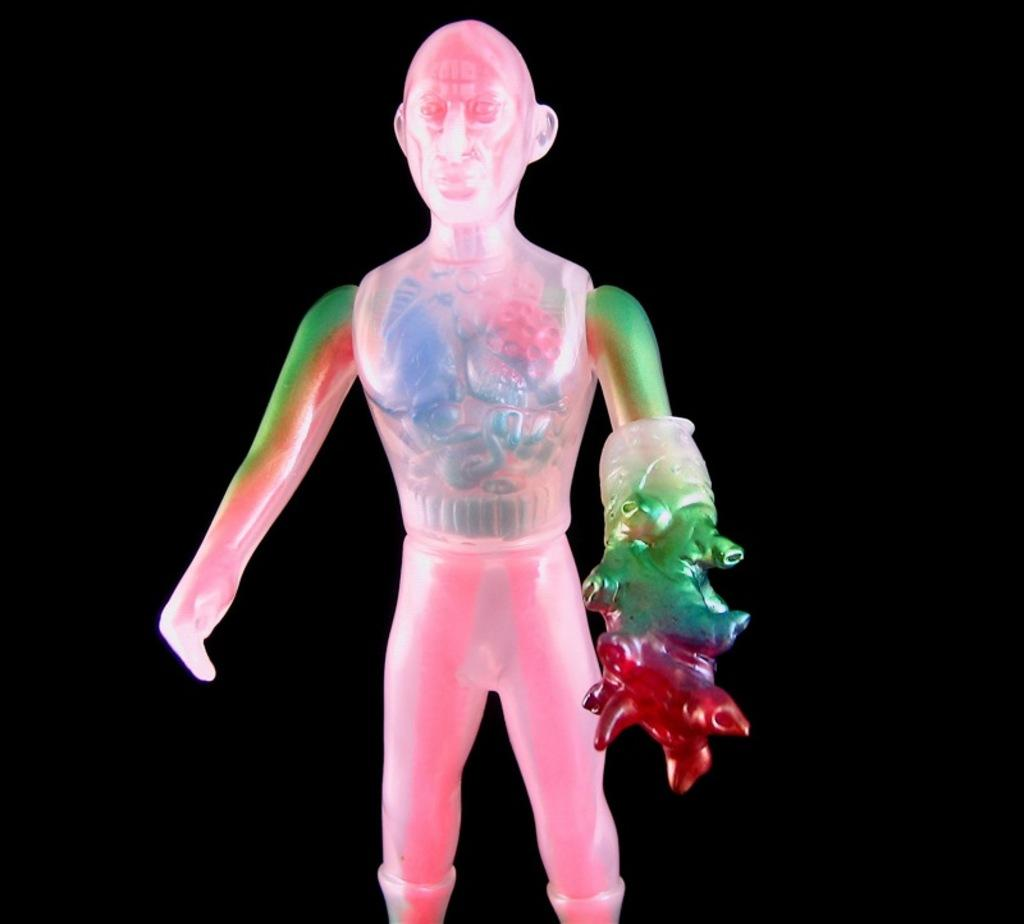What is the main object in the picture? There is a toy in the picture. What colors are used for the toy? The toy is in pink and green colors. What is the toy holding in its left hand? The toy has something in its left hand. How would you describe the background of the image? The backdrop of the image is dark. What type of war is being discussed in the story depicted in the image? There is no war or story present in the image; it features a toy with pink and green colors holding something in its left hand against a dark backdrop. 